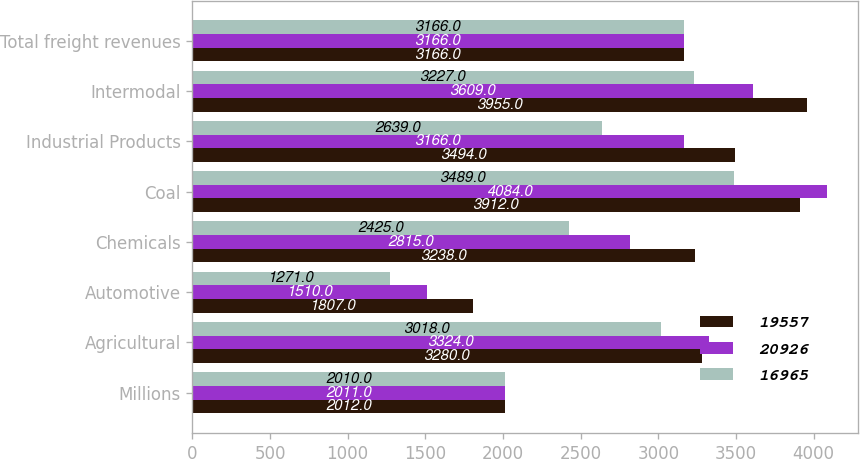Convert chart to OTSL. <chart><loc_0><loc_0><loc_500><loc_500><stacked_bar_chart><ecel><fcel>Millions<fcel>Agricultural<fcel>Automotive<fcel>Chemicals<fcel>Coal<fcel>Industrial Products<fcel>Intermodal<fcel>Total freight revenues<nl><fcel>19557<fcel>2012<fcel>3280<fcel>1807<fcel>3238<fcel>3912<fcel>3494<fcel>3955<fcel>3166<nl><fcel>20926<fcel>2011<fcel>3324<fcel>1510<fcel>2815<fcel>4084<fcel>3166<fcel>3609<fcel>3166<nl><fcel>16965<fcel>2010<fcel>3018<fcel>1271<fcel>2425<fcel>3489<fcel>2639<fcel>3227<fcel>3166<nl></chart> 